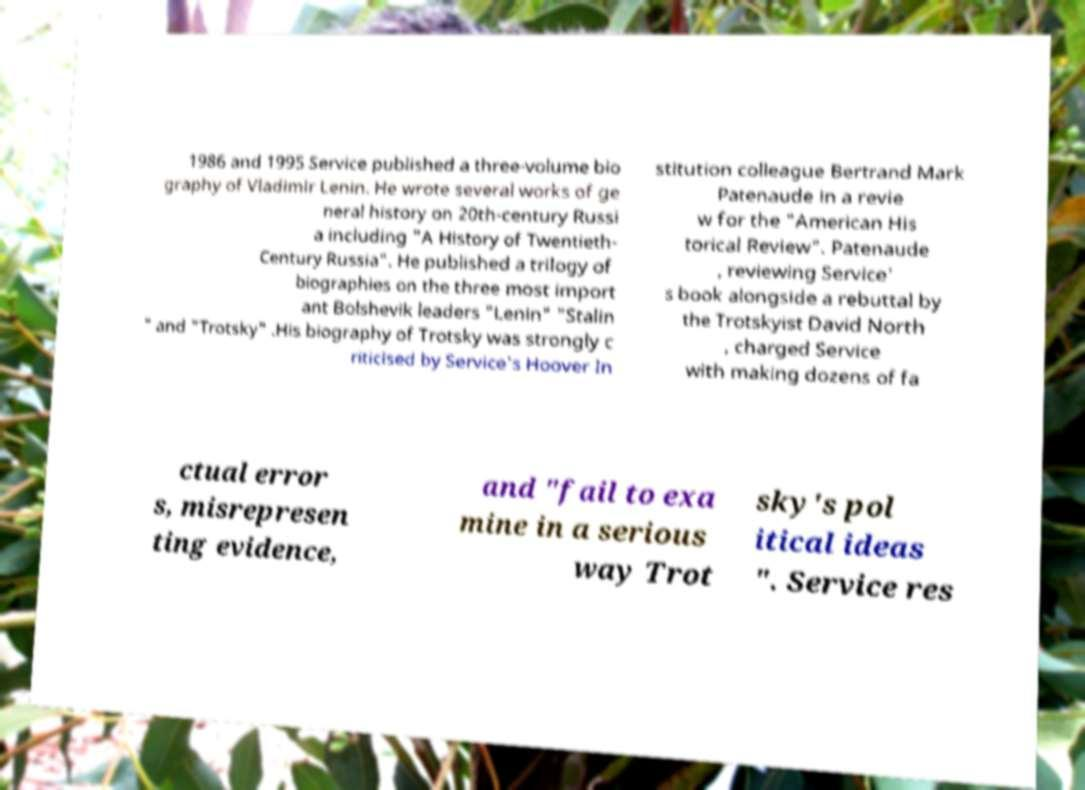There's text embedded in this image that I need extracted. Can you transcribe it verbatim? 1986 and 1995 Service published a three-volume bio graphy of Vladimir Lenin. He wrote several works of ge neral history on 20th-century Russi a including "A History of Twentieth- Century Russia". He published a trilogy of biographies on the three most import ant Bolshevik leaders "Lenin" "Stalin " and "Trotsky" .His biography of Trotsky was strongly c riticised by Service's Hoover In stitution colleague Bertrand Mark Patenaude in a revie w for the "American His torical Review". Patenaude , reviewing Service' s book alongside a rebuttal by the Trotskyist David North , charged Service with making dozens of fa ctual error s, misrepresen ting evidence, and "fail to exa mine in a serious way Trot sky's pol itical ideas ". Service res 